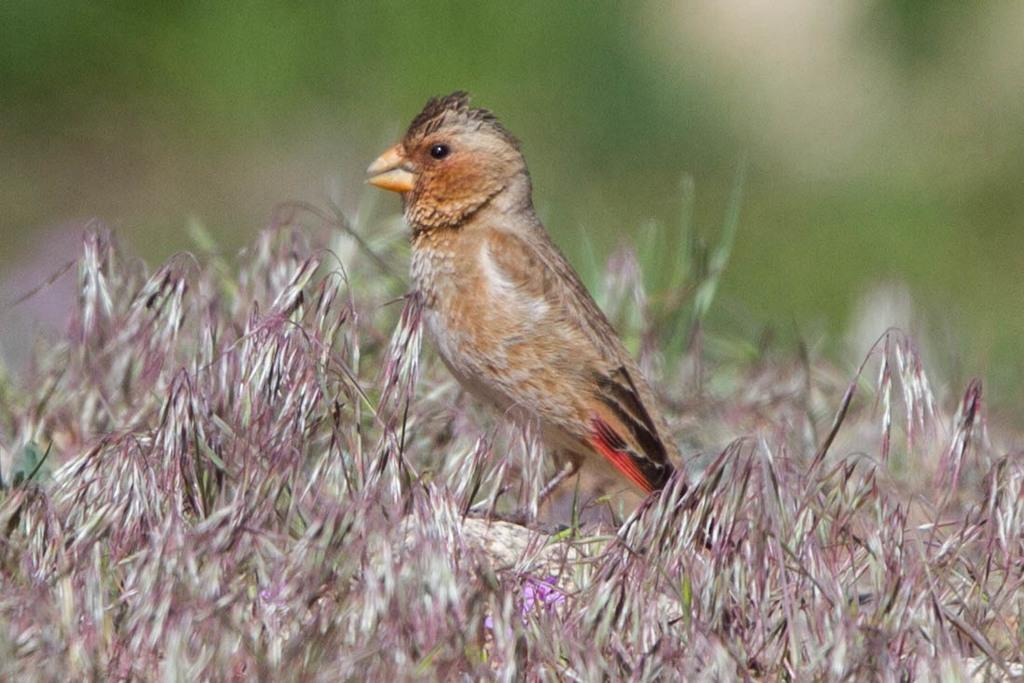What type of animal is present in the image? There is a bird in the image. What type of vegetation can be seen in the image? There is grass in the image. Can you describe the background of the image? The background appears to be blurred. Is there any other plant life visible in the image? There may be a flower in the image, but this is less certain than the other facts. What type of pizzas are being cooked in the fire in the image? There is no fire or pizzas present in the image; it features a bird and grass with a blurred background. 